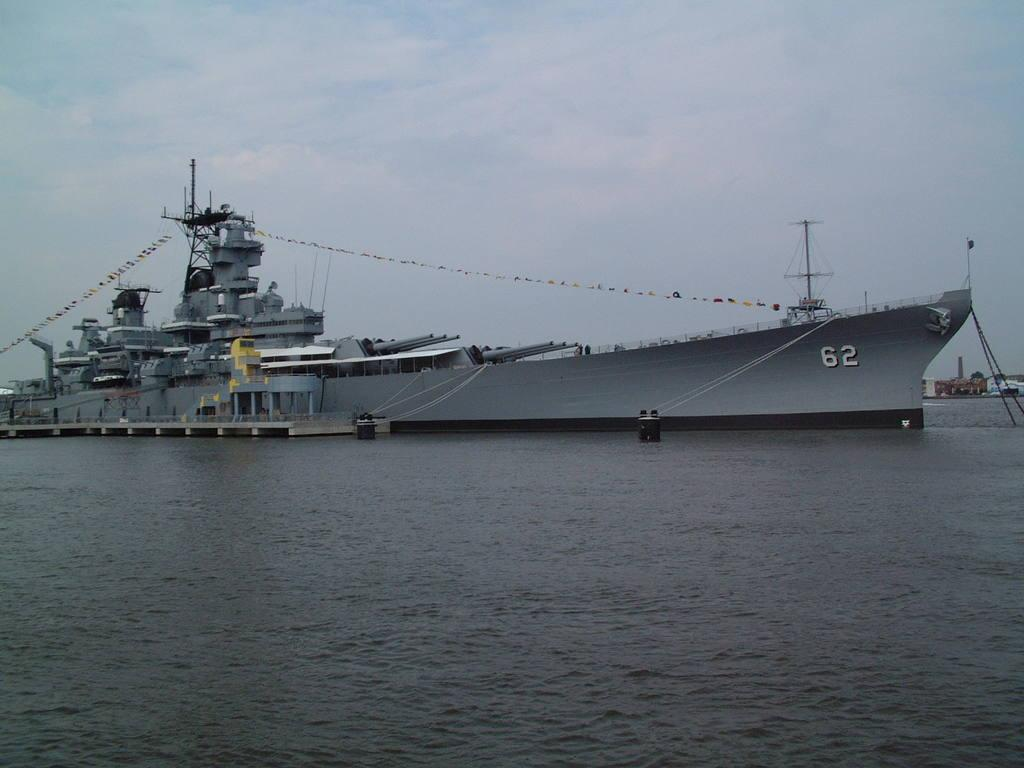What is the main subject of the image? There is a big ship in the image. What color is the ship? The ship is gray in color. What is visible at the bottom of the image? There is water at the bottom of the image. What is visible at the top of the image? There are clouds in the sky at the top of the image. What type of holiday is being celebrated on the ship in the image? There is no indication of a holiday being celebrated on the ship in the image. Can you describe the street where the ship is docked in the image? There is no street visible in the image; it only shows the ship on water. 